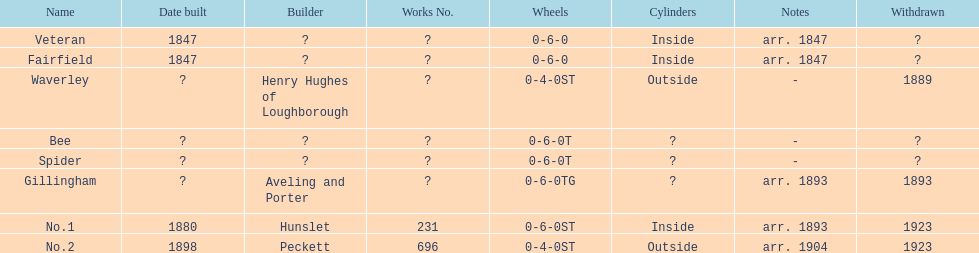What duration passed after fairfield was no. 1 constructed? 33 years. Parse the full table. {'header': ['Name', 'Date built', 'Builder', 'Works No.', 'Wheels', 'Cylinders', 'Notes', 'Withdrawn'], 'rows': [['Veteran', '1847', '?', '?', '0-6-0', 'Inside', 'arr. 1847', '?'], ['Fairfield', '1847', '?', '?', '0-6-0', 'Inside', 'arr. 1847', '?'], ['Waverley', '?', 'Henry Hughes of Loughborough', '?', '0-4-0ST', 'Outside', '-', '1889'], ['Bee', '?', '?', '?', '0-6-0T', '?', '-', '?'], ['Spider', '?', '?', '?', '0-6-0T', '?', '-', '?'], ['Gillingham', '?', 'Aveling and Porter', '?', '0-6-0TG', '?', 'arr. 1893', '1893'], ['No.1', '1880', 'Hunslet', '231', '0-6-0ST', 'Inside', 'arr. 1893', '1923'], ['No.2', '1898', 'Peckett', '696', '0-4-0ST', 'Outside', 'arr. 1904', '1923']]} 